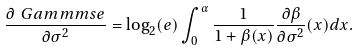<formula> <loc_0><loc_0><loc_500><loc_500>\frac { \partial \ G a m m m s e } { \partial \sigma ^ { 2 } } = \log _ { 2 } ( e ) \int _ { 0 } ^ { \alpha } \frac { 1 } { 1 + \beta ( x ) } \frac { \partial \beta } { \partial { \sigma ^ { 2 } } } ( x ) d x .</formula> 